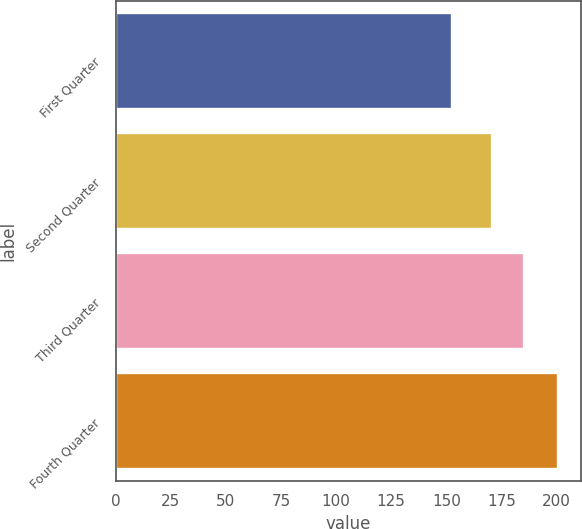<chart> <loc_0><loc_0><loc_500><loc_500><bar_chart><fcel>First Quarter<fcel>Second Quarter<fcel>Third Quarter<fcel>Fourth Quarter<nl><fcel>152.51<fcel>170.96<fcel>185.23<fcel>200.86<nl></chart> 